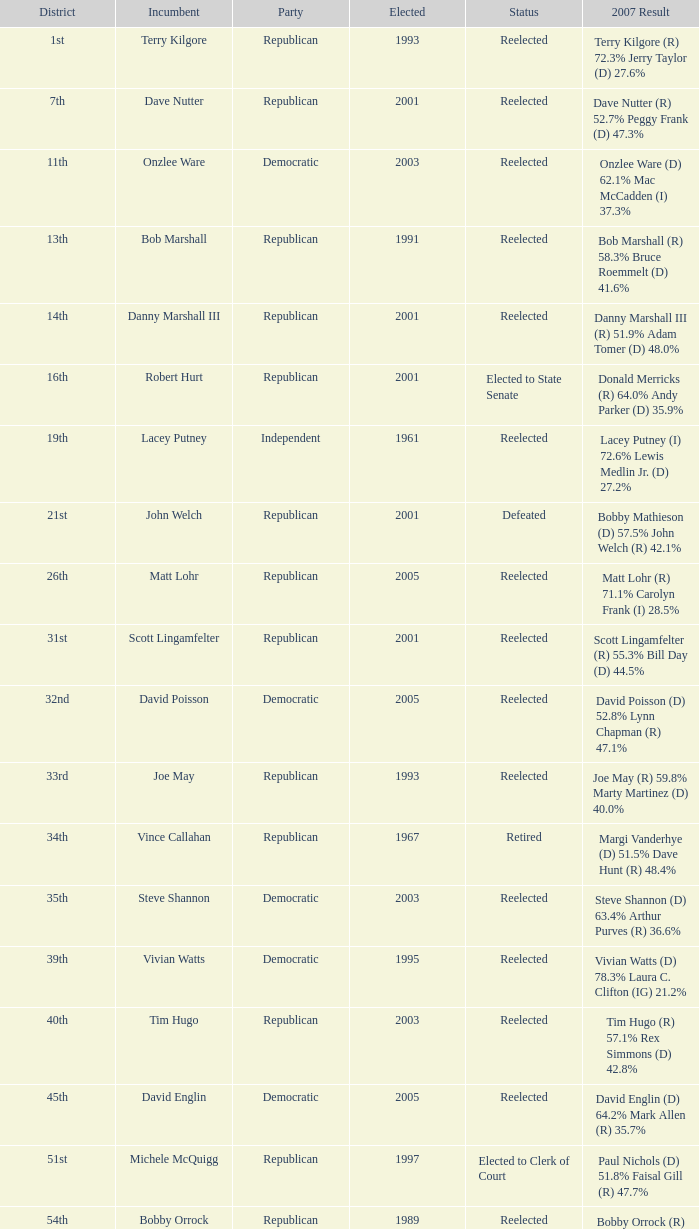How many voting outcomes are there from the 19th district? 1.0. 